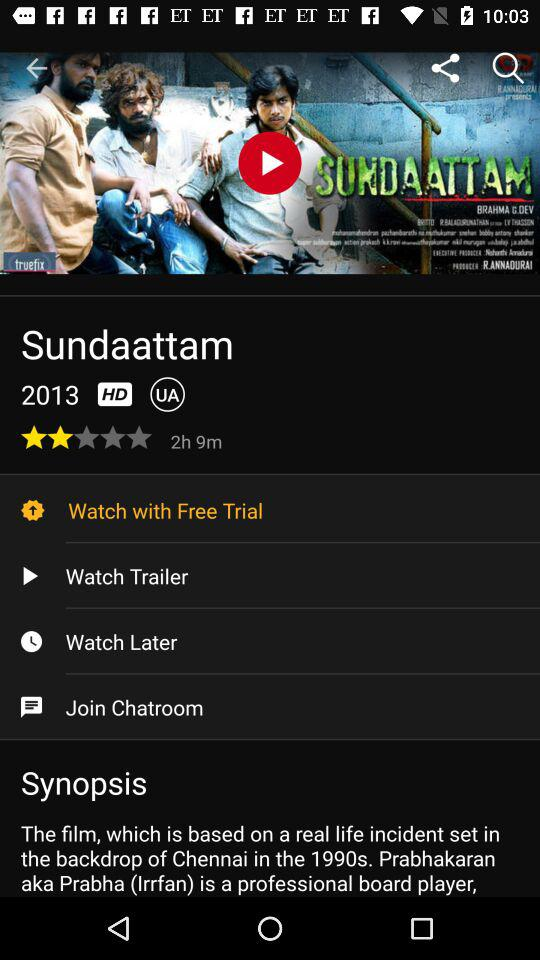What option has been selected? The option that has been selected is "Watch with Free Trial". 